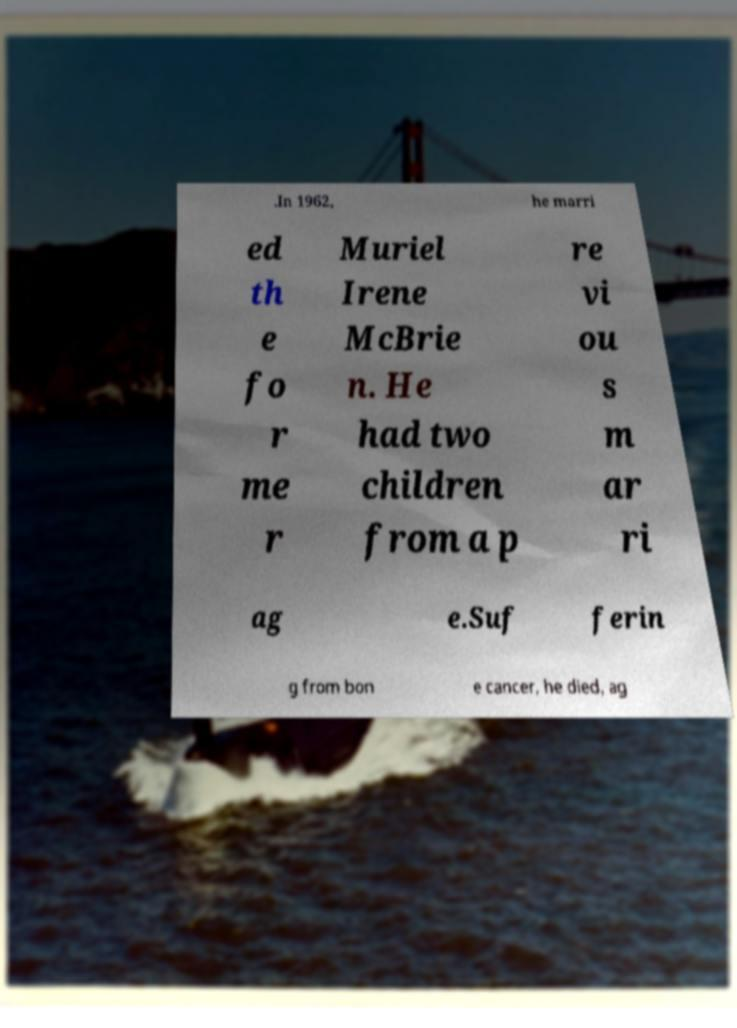Please identify and transcribe the text found in this image. .In 1962, he marri ed th e fo r me r Muriel Irene McBrie n. He had two children from a p re vi ou s m ar ri ag e.Suf ferin g from bon e cancer, he died, ag 